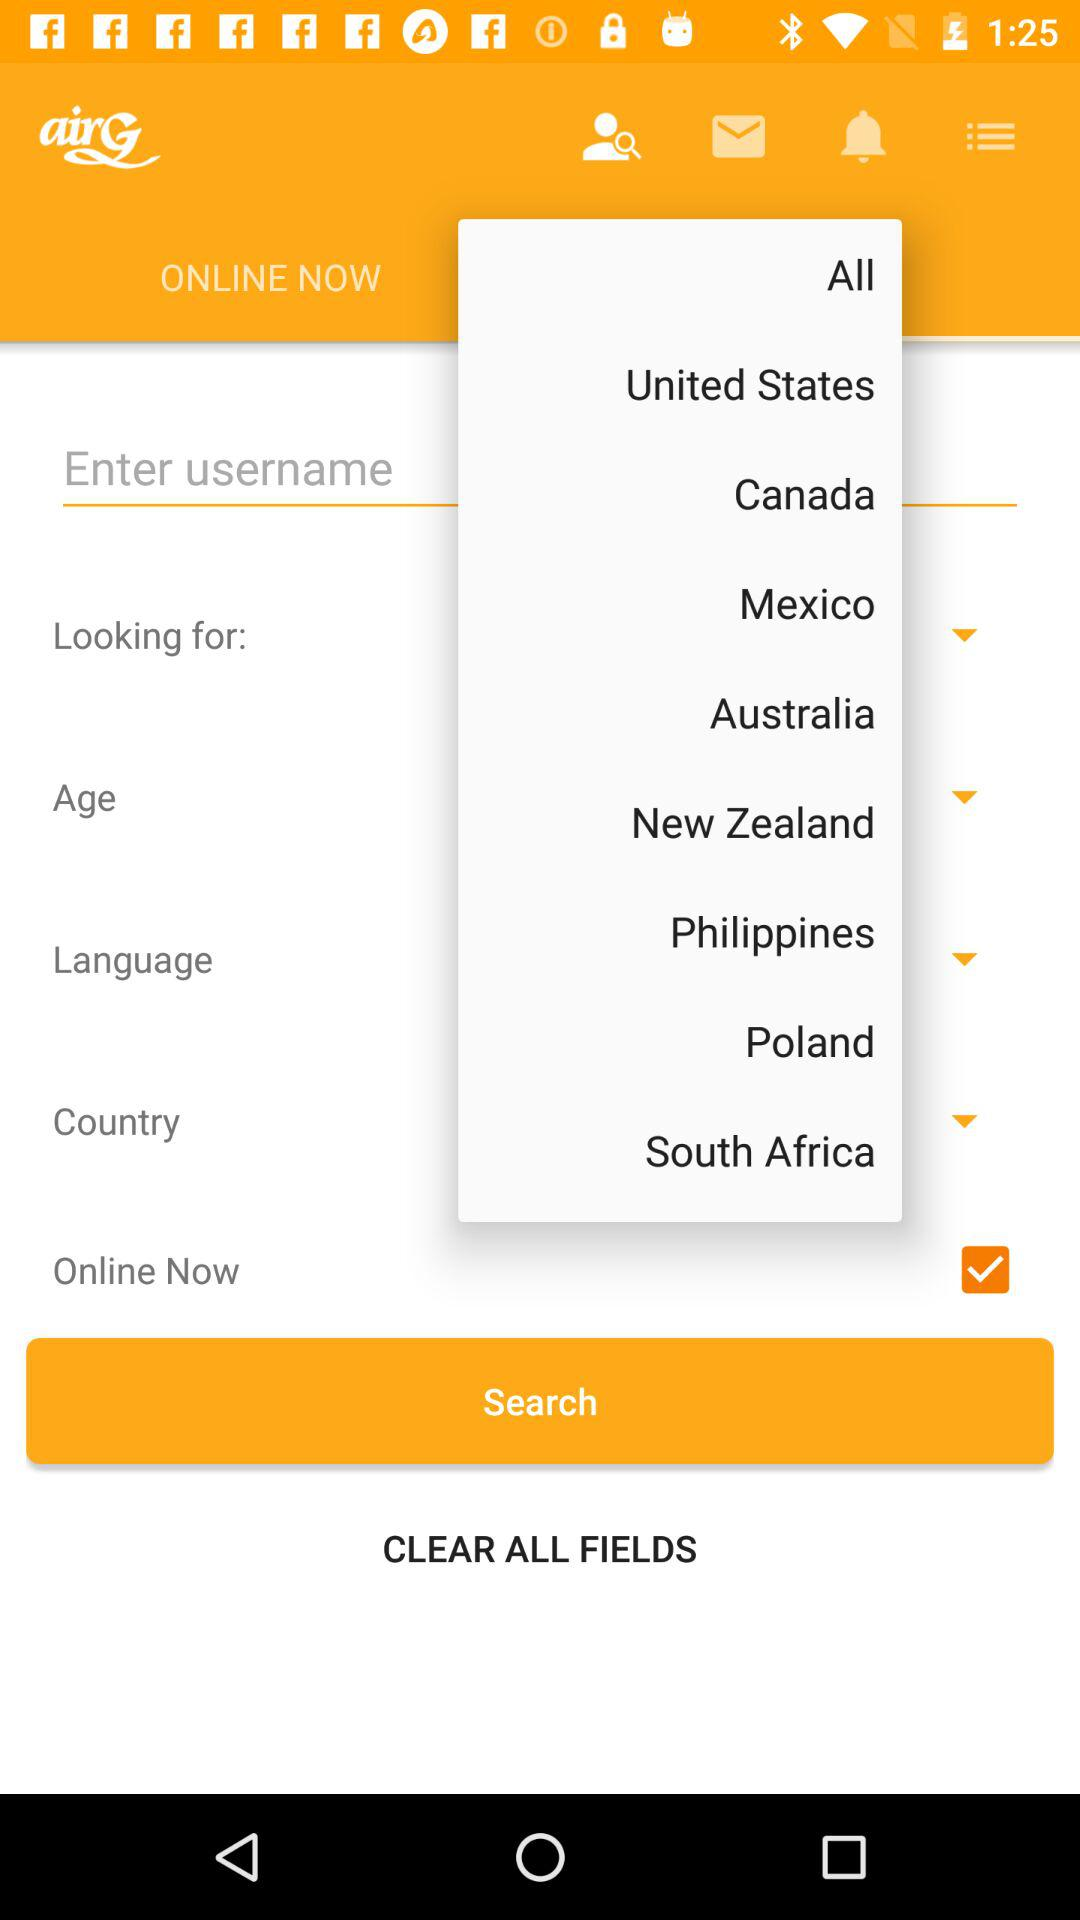What is the status of "online now"? The status is "on". 